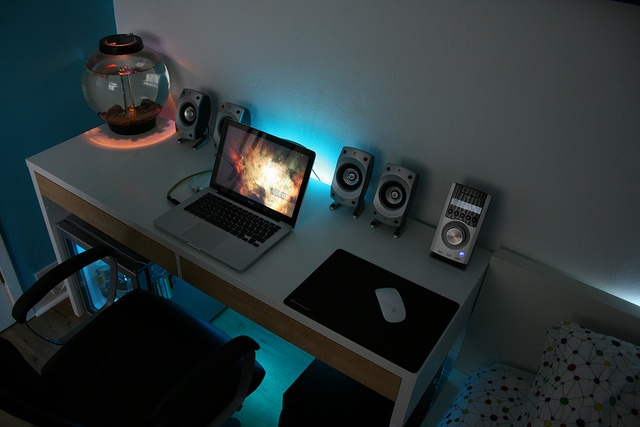Describe the objects in this image and their specific colors. I can see chair in black, blue, darkblue, and gray tones, bed in black, darkblue, purple, and teal tones, laptop in black, gray, beige, and tan tones, vase in black, gray, purple, and maroon tones, and keyboard in black and purple tones in this image. 